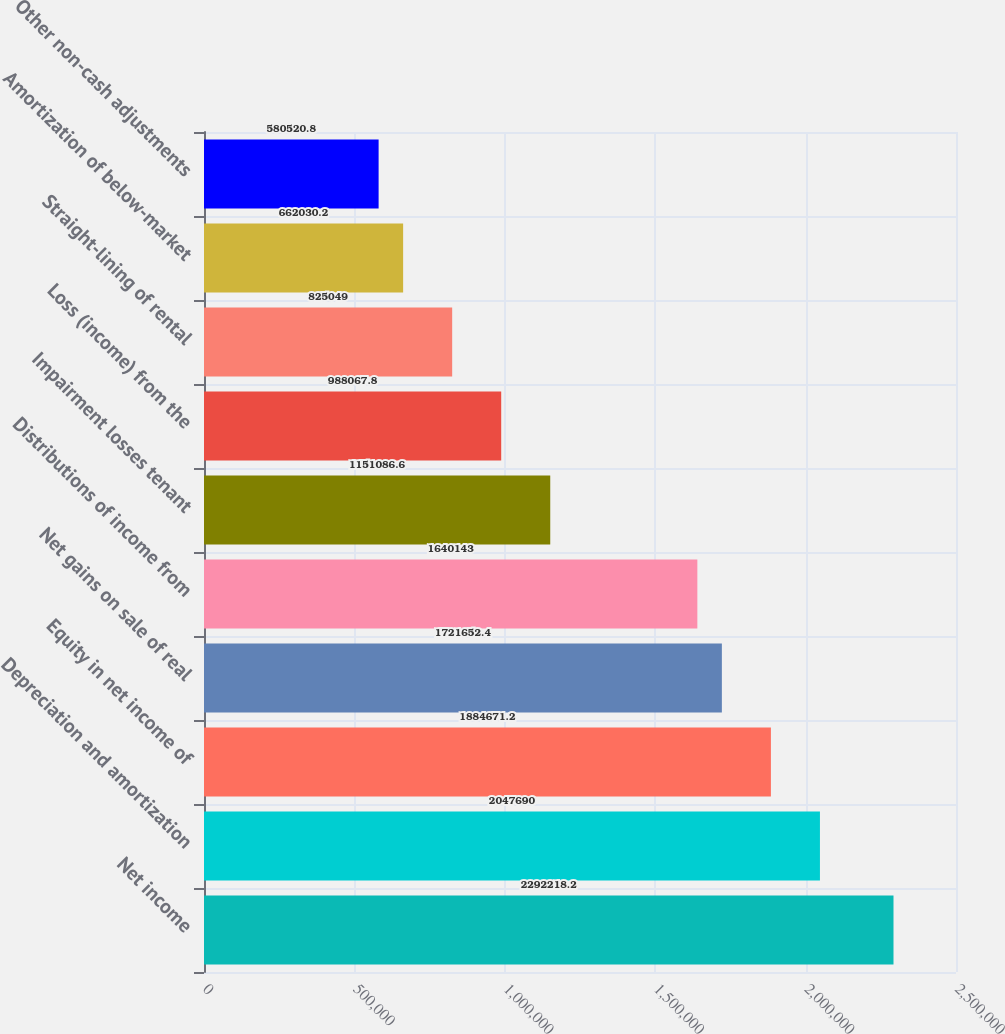Convert chart. <chart><loc_0><loc_0><loc_500><loc_500><bar_chart><fcel>Net income<fcel>Depreciation and amortization<fcel>Equity in net income of<fcel>Net gains on sale of real<fcel>Distributions of income from<fcel>Impairment losses tenant<fcel>Loss (income) from the<fcel>Straight-lining of rental<fcel>Amortization of below-market<fcel>Other non-cash adjustments<nl><fcel>2.29222e+06<fcel>2.04769e+06<fcel>1.88467e+06<fcel>1.72165e+06<fcel>1.64014e+06<fcel>1.15109e+06<fcel>988068<fcel>825049<fcel>662030<fcel>580521<nl></chart> 